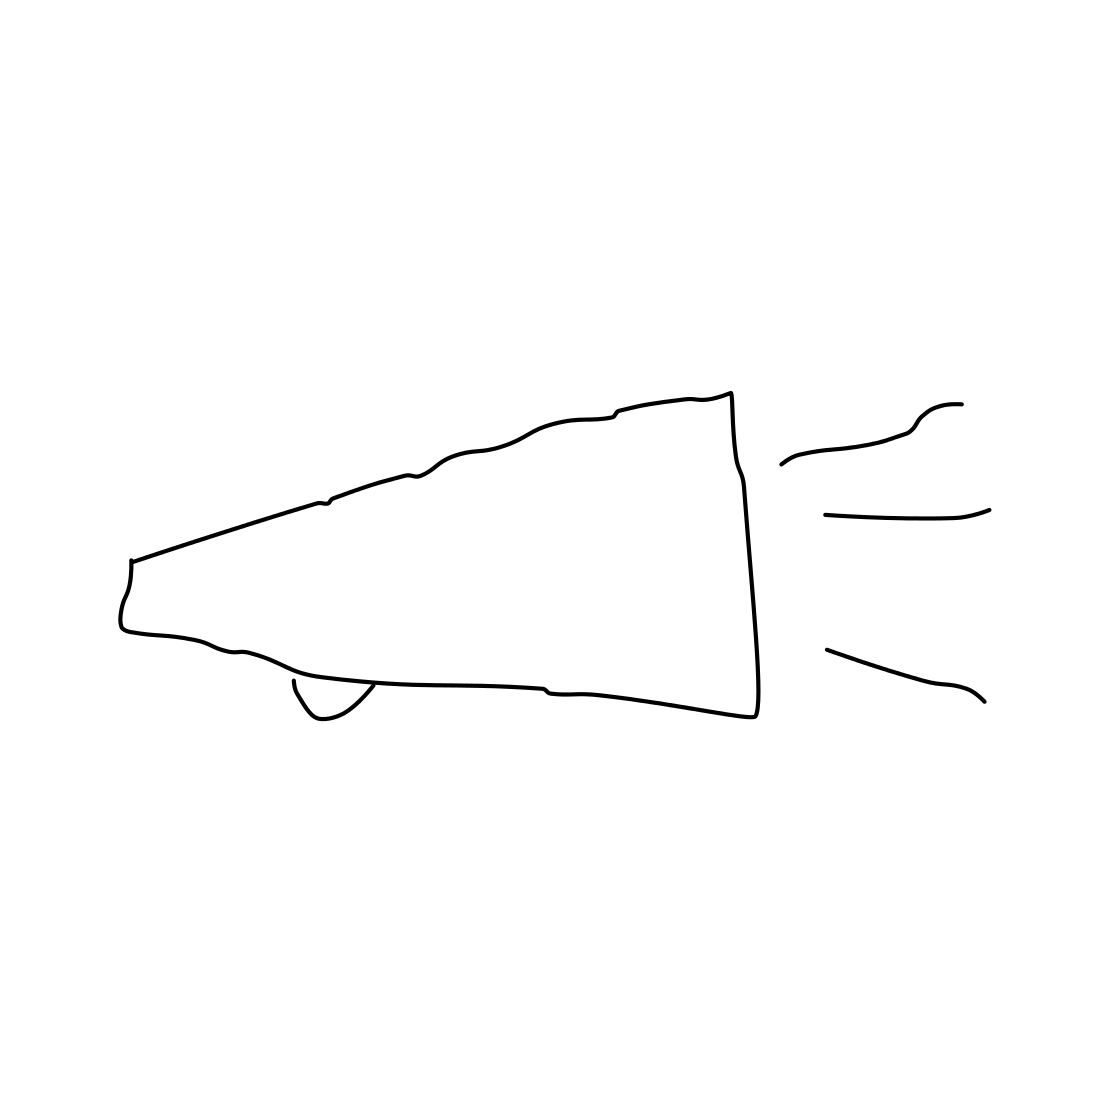What purpose does a megaphone generally serve? A megaphone is typically used to amplify a person's voice, making it louder, so that the sound can cover larger distances. It's often utilized in various settings, like sporting events, rallies, or in situations where someone needs to address a crowd. 